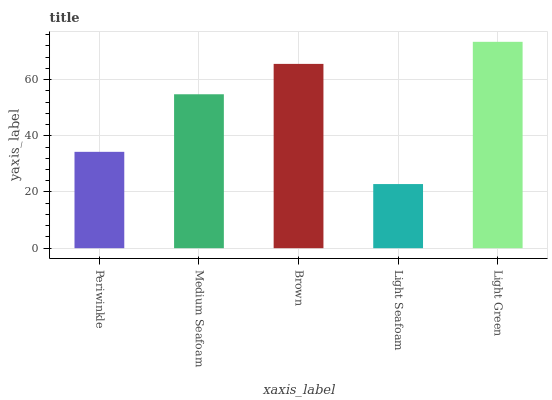Is Light Seafoam the minimum?
Answer yes or no. Yes. Is Light Green the maximum?
Answer yes or no. Yes. Is Medium Seafoam the minimum?
Answer yes or no. No. Is Medium Seafoam the maximum?
Answer yes or no. No. Is Medium Seafoam greater than Periwinkle?
Answer yes or no. Yes. Is Periwinkle less than Medium Seafoam?
Answer yes or no. Yes. Is Periwinkle greater than Medium Seafoam?
Answer yes or no. No. Is Medium Seafoam less than Periwinkle?
Answer yes or no. No. Is Medium Seafoam the high median?
Answer yes or no. Yes. Is Medium Seafoam the low median?
Answer yes or no. Yes. Is Periwinkle the high median?
Answer yes or no. No. Is Light Green the low median?
Answer yes or no. No. 